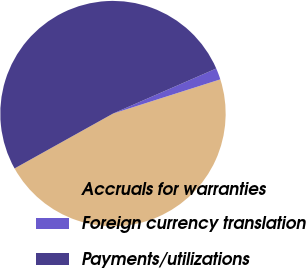Convert chart. <chart><loc_0><loc_0><loc_500><loc_500><pie_chart><fcel>Accruals for warranties<fcel>Foreign currency translation<fcel>Payments/utilizations<nl><fcel>46.82%<fcel>1.64%<fcel>51.54%<nl></chart> 